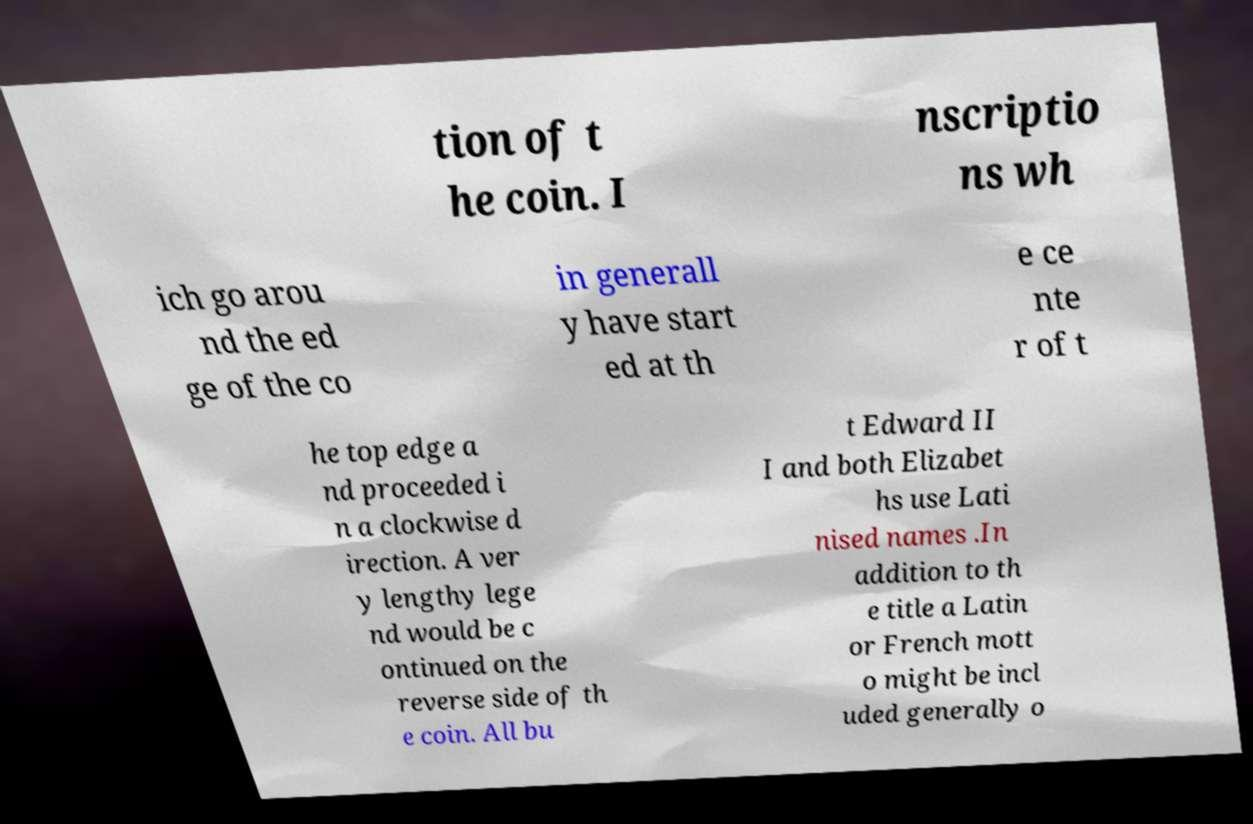Could you extract and type out the text from this image? tion of t he coin. I nscriptio ns wh ich go arou nd the ed ge of the co in generall y have start ed at th e ce nte r of t he top edge a nd proceeded i n a clockwise d irection. A ver y lengthy lege nd would be c ontinued on the reverse side of th e coin. All bu t Edward II I and both Elizabet hs use Lati nised names .In addition to th e title a Latin or French mott o might be incl uded generally o 